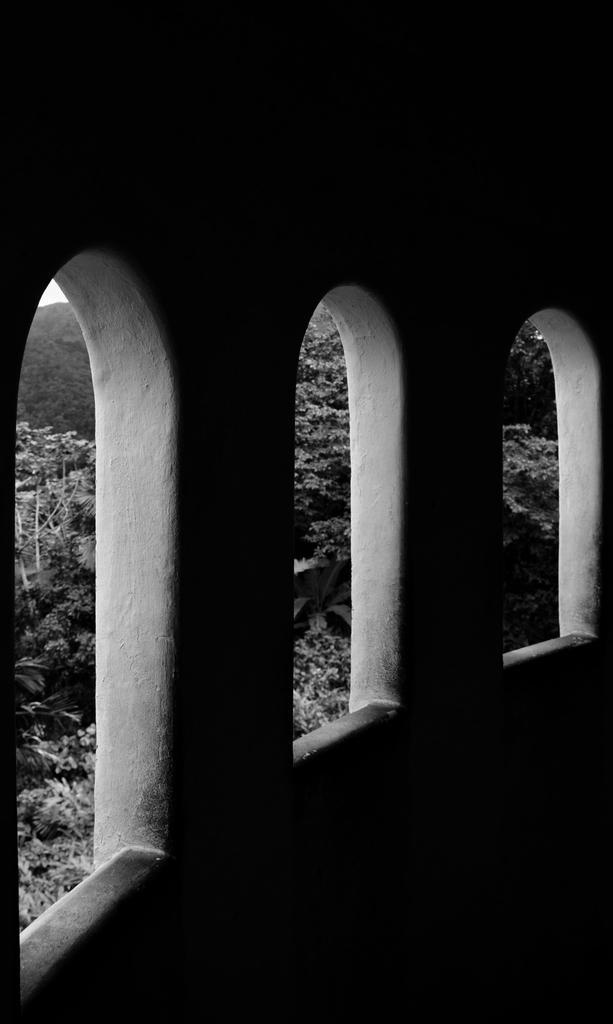How many windows are present in the image? There are three windows in the image. What can be seen through the windows? Trees are visible through the windows. What is the color of the background in the image? The background of the image is dark. What type of organization is depicted in the image? There is no organization depicted in the image; it features windows and trees. How many ducks are visible in the image? There are no ducks present in the image. 